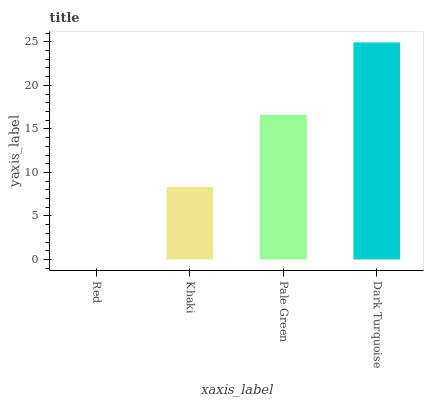Is Red the minimum?
Answer yes or no. Yes. Is Dark Turquoise the maximum?
Answer yes or no. Yes. Is Khaki the minimum?
Answer yes or no. No. Is Khaki the maximum?
Answer yes or no. No. Is Khaki greater than Red?
Answer yes or no. Yes. Is Red less than Khaki?
Answer yes or no. Yes. Is Red greater than Khaki?
Answer yes or no. No. Is Khaki less than Red?
Answer yes or no. No. Is Pale Green the high median?
Answer yes or no. Yes. Is Khaki the low median?
Answer yes or no. Yes. Is Khaki the high median?
Answer yes or no. No. Is Red the low median?
Answer yes or no. No. 